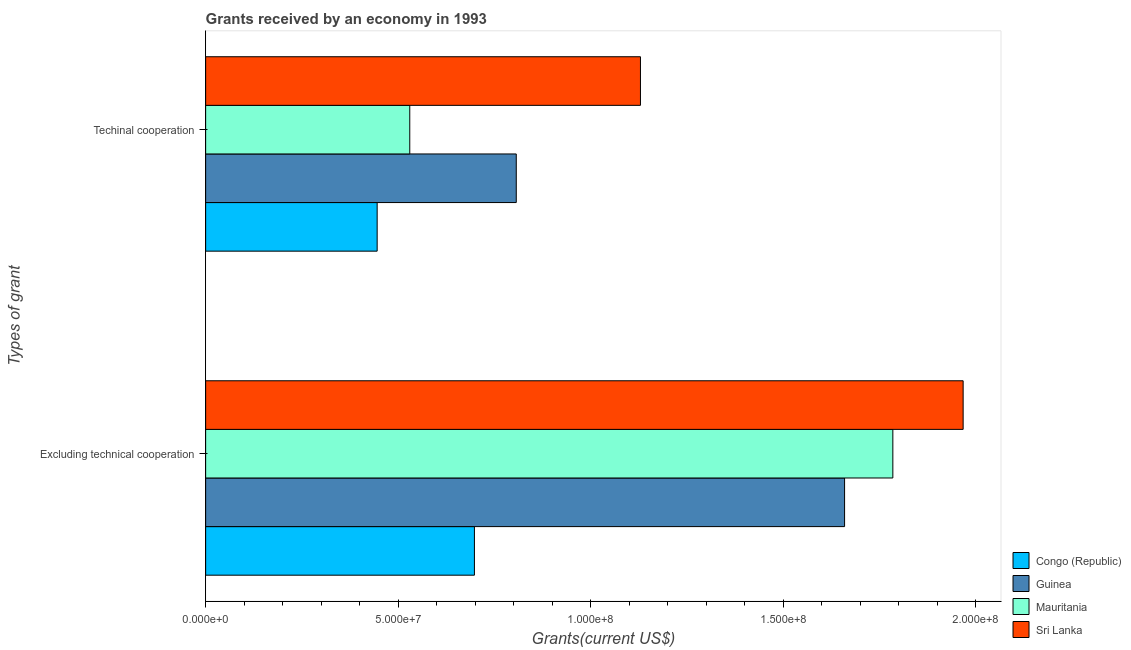How many different coloured bars are there?
Make the answer very short. 4. How many groups of bars are there?
Offer a terse response. 2. Are the number of bars on each tick of the Y-axis equal?
Your answer should be compact. Yes. How many bars are there on the 2nd tick from the top?
Provide a succinct answer. 4. How many bars are there on the 2nd tick from the bottom?
Provide a succinct answer. 4. What is the label of the 1st group of bars from the top?
Provide a succinct answer. Techinal cooperation. What is the amount of grants received(excluding technical cooperation) in Mauritania?
Give a very brief answer. 1.79e+08. Across all countries, what is the maximum amount of grants received(including technical cooperation)?
Ensure brevity in your answer.  1.13e+08. Across all countries, what is the minimum amount of grants received(excluding technical cooperation)?
Keep it short and to the point. 6.98e+07. In which country was the amount of grants received(excluding technical cooperation) maximum?
Keep it short and to the point. Sri Lanka. In which country was the amount of grants received(excluding technical cooperation) minimum?
Ensure brevity in your answer.  Congo (Republic). What is the total amount of grants received(including technical cooperation) in the graph?
Your answer should be compact. 2.91e+08. What is the difference between the amount of grants received(excluding technical cooperation) in Sri Lanka and that in Guinea?
Your response must be concise. 3.08e+07. What is the difference between the amount of grants received(including technical cooperation) in Sri Lanka and the amount of grants received(excluding technical cooperation) in Guinea?
Provide a succinct answer. -5.30e+07. What is the average amount of grants received(excluding technical cooperation) per country?
Make the answer very short. 1.53e+08. What is the difference between the amount of grants received(excluding technical cooperation) and amount of grants received(including technical cooperation) in Guinea?
Make the answer very short. 8.53e+07. In how many countries, is the amount of grants received(excluding technical cooperation) greater than 150000000 US$?
Provide a short and direct response. 3. What is the ratio of the amount of grants received(including technical cooperation) in Mauritania to that in Congo (Republic)?
Offer a very short reply. 1.19. In how many countries, is the amount of grants received(including technical cooperation) greater than the average amount of grants received(including technical cooperation) taken over all countries?
Give a very brief answer. 2. What does the 1st bar from the top in Excluding technical cooperation represents?
Offer a very short reply. Sri Lanka. What does the 3rd bar from the bottom in Excluding technical cooperation represents?
Ensure brevity in your answer.  Mauritania. How many bars are there?
Provide a short and direct response. 8. How many countries are there in the graph?
Provide a succinct answer. 4. Does the graph contain any zero values?
Provide a succinct answer. No. Does the graph contain grids?
Offer a very short reply. No. What is the title of the graph?
Offer a terse response. Grants received by an economy in 1993. Does "Isle of Man" appear as one of the legend labels in the graph?
Offer a very short reply. No. What is the label or title of the X-axis?
Offer a very short reply. Grants(current US$). What is the label or title of the Y-axis?
Your response must be concise. Types of grant. What is the Grants(current US$) of Congo (Republic) in Excluding technical cooperation?
Keep it short and to the point. 6.98e+07. What is the Grants(current US$) of Guinea in Excluding technical cooperation?
Offer a terse response. 1.66e+08. What is the Grants(current US$) of Mauritania in Excluding technical cooperation?
Offer a very short reply. 1.79e+08. What is the Grants(current US$) in Sri Lanka in Excluding technical cooperation?
Keep it short and to the point. 1.97e+08. What is the Grants(current US$) of Congo (Republic) in Techinal cooperation?
Offer a very short reply. 4.46e+07. What is the Grants(current US$) of Guinea in Techinal cooperation?
Your answer should be very brief. 8.07e+07. What is the Grants(current US$) of Mauritania in Techinal cooperation?
Your response must be concise. 5.30e+07. What is the Grants(current US$) in Sri Lanka in Techinal cooperation?
Provide a short and direct response. 1.13e+08. Across all Types of grant, what is the maximum Grants(current US$) in Congo (Republic)?
Your response must be concise. 6.98e+07. Across all Types of grant, what is the maximum Grants(current US$) of Guinea?
Keep it short and to the point. 1.66e+08. Across all Types of grant, what is the maximum Grants(current US$) of Mauritania?
Provide a succinct answer. 1.79e+08. Across all Types of grant, what is the maximum Grants(current US$) of Sri Lanka?
Your response must be concise. 1.97e+08. Across all Types of grant, what is the minimum Grants(current US$) of Congo (Republic)?
Your answer should be compact. 4.46e+07. Across all Types of grant, what is the minimum Grants(current US$) in Guinea?
Provide a succinct answer. 8.07e+07. Across all Types of grant, what is the minimum Grants(current US$) of Mauritania?
Offer a very short reply. 5.30e+07. Across all Types of grant, what is the minimum Grants(current US$) in Sri Lanka?
Make the answer very short. 1.13e+08. What is the total Grants(current US$) of Congo (Republic) in the graph?
Give a very brief answer. 1.14e+08. What is the total Grants(current US$) of Guinea in the graph?
Offer a terse response. 2.47e+08. What is the total Grants(current US$) of Mauritania in the graph?
Your answer should be compact. 2.32e+08. What is the total Grants(current US$) in Sri Lanka in the graph?
Keep it short and to the point. 3.10e+08. What is the difference between the Grants(current US$) of Congo (Republic) in Excluding technical cooperation and that in Techinal cooperation?
Provide a short and direct response. 2.53e+07. What is the difference between the Grants(current US$) of Guinea in Excluding technical cooperation and that in Techinal cooperation?
Keep it short and to the point. 8.53e+07. What is the difference between the Grants(current US$) in Mauritania in Excluding technical cooperation and that in Techinal cooperation?
Give a very brief answer. 1.26e+08. What is the difference between the Grants(current US$) of Sri Lanka in Excluding technical cooperation and that in Techinal cooperation?
Offer a terse response. 8.38e+07. What is the difference between the Grants(current US$) of Congo (Republic) in Excluding technical cooperation and the Grants(current US$) of Guinea in Techinal cooperation?
Give a very brief answer. -1.09e+07. What is the difference between the Grants(current US$) in Congo (Republic) in Excluding technical cooperation and the Grants(current US$) in Mauritania in Techinal cooperation?
Your answer should be compact. 1.68e+07. What is the difference between the Grants(current US$) of Congo (Republic) in Excluding technical cooperation and the Grants(current US$) of Sri Lanka in Techinal cooperation?
Make the answer very short. -4.31e+07. What is the difference between the Grants(current US$) in Guinea in Excluding technical cooperation and the Grants(current US$) in Mauritania in Techinal cooperation?
Offer a terse response. 1.13e+08. What is the difference between the Grants(current US$) in Guinea in Excluding technical cooperation and the Grants(current US$) in Sri Lanka in Techinal cooperation?
Offer a very short reply. 5.30e+07. What is the difference between the Grants(current US$) of Mauritania in Excluding technical cooperation and the Grants(current US$) of Sri Lanka in Techinal cooperation?
Ensure brevity in your answer.  6.56e+07. What is the average Grants(current US$) of Congo (Republic) per Types of grant?
Offer a very short reply. 5.72e+07. What is the average Grants(current US$) of Guinea per Types of grant?
Your response must be concise. 1.23e+08. What is the average Grants(current US$) in Mauritania per Types of grant?
Offer a terse response. 1.16e+08. What is the average Grants(current US$) in Sri Lanka per Types of grant?
Ensure brevity in your answer.  1.55e+08. What is the difference between the Grants(current US$) in Congo (Republic) and Grants(current US$) in Guinea in Excluding technical cooperation?
Your answer should be very brief. -9.62e+07. What is the difference between the Grants(current US$) of Congo (Republic) and Grants(current US$) of Mauritania in Excluding technical cooperation?
Offer a terse response. -1.09e+08. What is the difference between the Grants(current US$) of Congo (Republic) and Grants(current US$) of Sri Lanka in Excluding technical cooperation?
Your answer should be very brief. -1.27e+08. What is the difference between the Grants(current US$) of Guinea and Grants(current US$) of Mauritania in Excluding technical cooperation?
Provide a succinct answer. -1.25e+07. What is the difference between the Grants(current US$) in Guinea and Grants(current US$) in Sri Lanka in Excluding technical cooperation?
Provide a short and direct response. -3.08e+07. What is the difference between the Grants(current US$) in Mauritania and Grants(current US$) in Sri Lanka in Excluding technical cooperation?
Offer a terse response. -1.83e+07. What is the difference between the Grants(current US$) in Congo (Republic) and Grants(current US$) in Guinea in Techinal cooperation?
Your response must be concise. -3.61e+07. What is the difference between the Grants(current US$) in Congo (Republic) and Grants(current US$) in Mauritania in Techinal cooperation?
Offer a very short reply. -8.47e+06. What is the difference between the Grants(current US$) in Congo (Republic) and Grants(current US$) in Sri Lanka in Techinal cooperation?
Provide a short and direct response. -6.84e+07. What is the difference between the Grants(current US$) of Guinea and Grants(current US$) of Mauritania in Techinal cooperation?
Offer a very short reply. 2.77e+07. What is the difference between the Grants(current US$) in Guinea and Grants(current US$) in Sri Lanka in Techinal cooperation?
Your response must be concise. -3.23e+07. What is the difference between the Grants(current US$) in Mauritania and Grants(current US$) in Sri Lanka in Techinal cooperation?
Ensure brevity in your answer.  -5.99e+07. What is the ratio of the Grants(current US$) in Congo (Republic) in Excluding technical cooperation to that in Techinal cooperation?
Offer a very short reply. 1.57. What is the ratio of the Grants(current US$) of Guinea in Excluding technical cooperation to that in Techinal cooperation?
Ensure brevity in your answer.  2.06. What is the ratio of the Grants(current US$) in Mauritania in Excluding technical cooperation to that in Techinal cooperation?
Make the answer very short. 3.37. What is the ratio of the Grants(current US$) of Sri Lanka in Excluding technical cooperation to that in Techinal cooperation?
Your answer should be compact. 1.74. What is the difference between the highest and the second highest Grants(current US$) of Congo (Republic)?
Provide a succinct answer. 2.53e+07. What is the difference between the highest and the second highest Grants(current US$) of Guinea?
Keep it short and to the point. 8.53e+07. What is the difference between the highest and the second highest Grants(current US$) in Mauritania?
Your answer should be compact. 1.26e+08. What is the difference between the highest and the second highest Grants(current US$) in Sri Lanka?
Keep it short and to the point. 8.38e+07. What is the difference between the highest and the lowest Grants(current US$) of Congo (Republic)?
Your answer should be very brief. 2.53e+07. What is the difference between the highest and the lowest Grants(current US$) in Guinea?
Make the answer very short. 8.53e+07. What is the difference between the highest and the lowest Grants(current US$) in Mauritania?
Provide a short and direct response. 1.26e+08. What is the difference between the highest and the lowest Grants(current US$) in Sri Lanka?
Keep it short and to the point. 8.38e+07. 